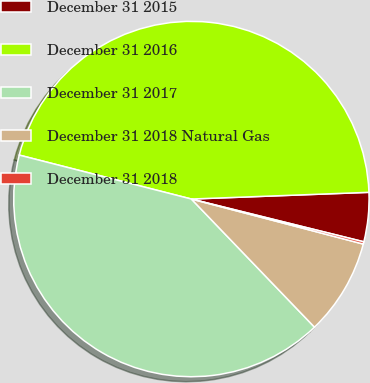<chart> <loc_0><loc_0><loc_500><loc_500><pie_chart><fcel>December 31 2015<fcel>December 31 2016<fcel>December 31 2017<fcel>December 31 2018 Natural Gas<fcel>December 31 2018<nl><fcel>4.47%<fcel>45.42%<fcel>41.16%<fcel>8.74%<fcel>0.21%<nl></chart> 